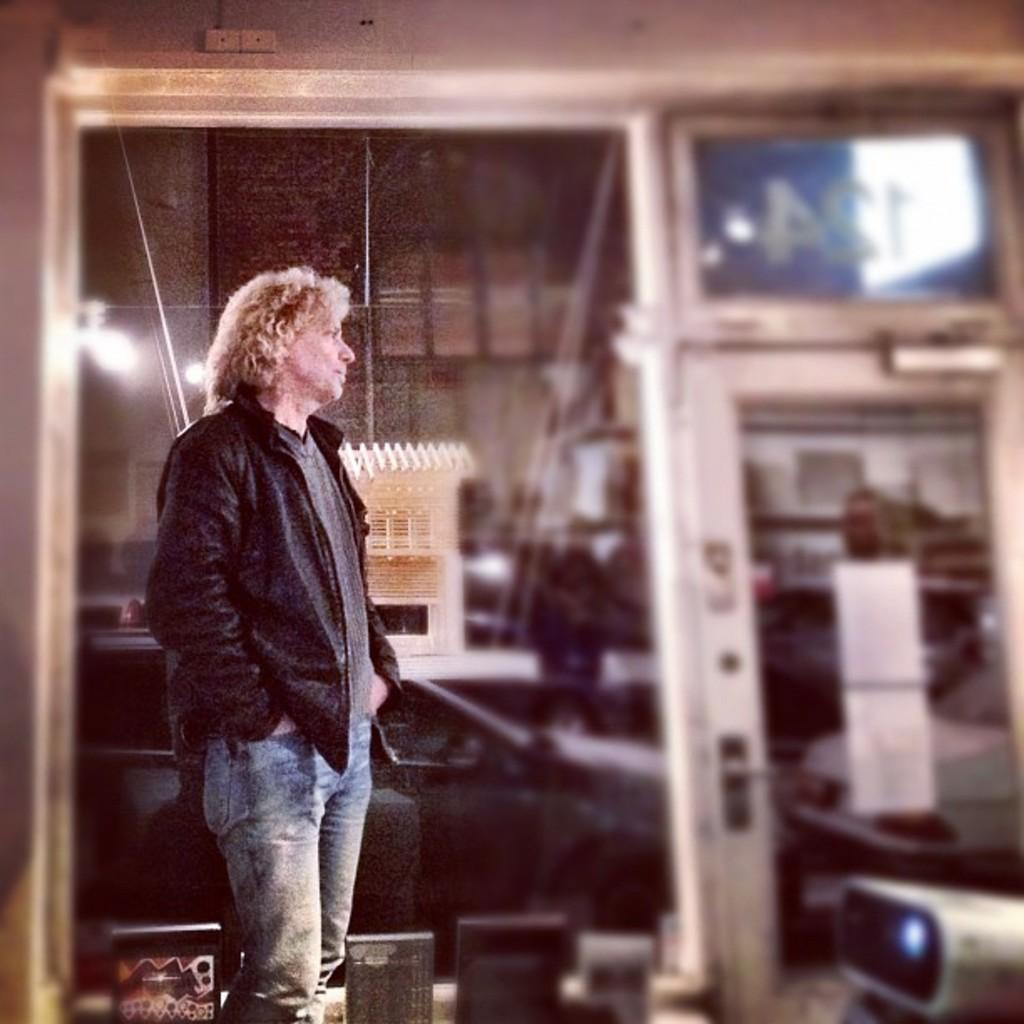What is the main subject in the image? There is a person standing in the image. What else can be seen in the image besides the person? There are objects, windows, doors, and posters in the image. What time of day is it in the image, and what is the porter doing? The time of day is not mentioned in the image, and there is no porter present. 